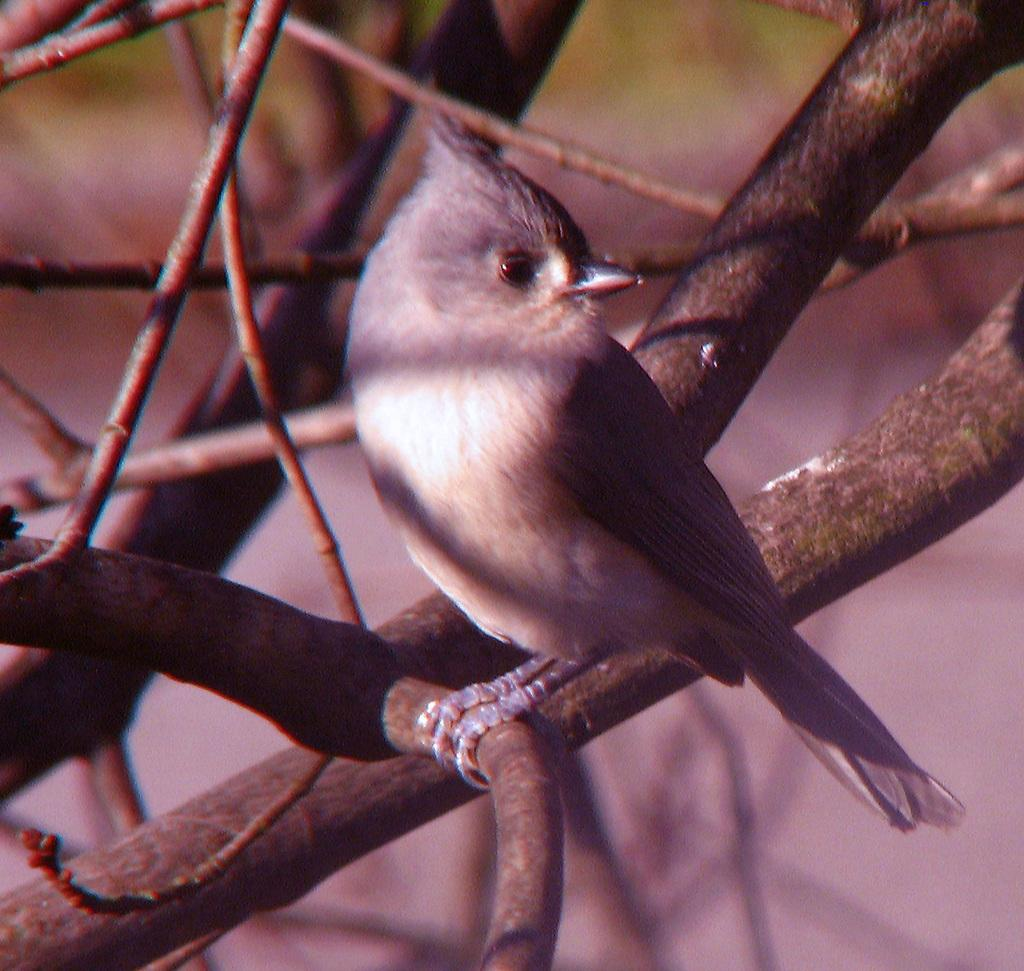What type of animal can be seen in the image? There is a bird in the image. Where is the bird located in the image? The bird is standing on a branch of a tree. What can be seen in the background of the image? The tree has branches and stems visible in the background. What type of paper is visible in the image? There is no paper present in the image; it features a bird standing on a tree branch. 